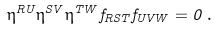<formula> <loc_0><loc_0><loc_500><loc_500>\eta ^ { R U } \eta ^ { S V } \eta ^ { T W } f _ { R S T } f _ { U V W } = 0 \, .</formula> 